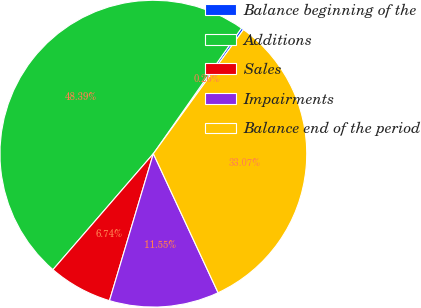Convert chart. <chart><loc_0><loc_0><loc_500><loc_500><pie_chart><fcel>Balance beginning of the<fcel>Additions<fcel>Sales<fcel>Impairments<fcel>Balance end of the period<nl><fcel>0.26%<fcel>48.39%<fcel>6.74%<fcel>11.55%<fcel>33.07%<nl></chart> 